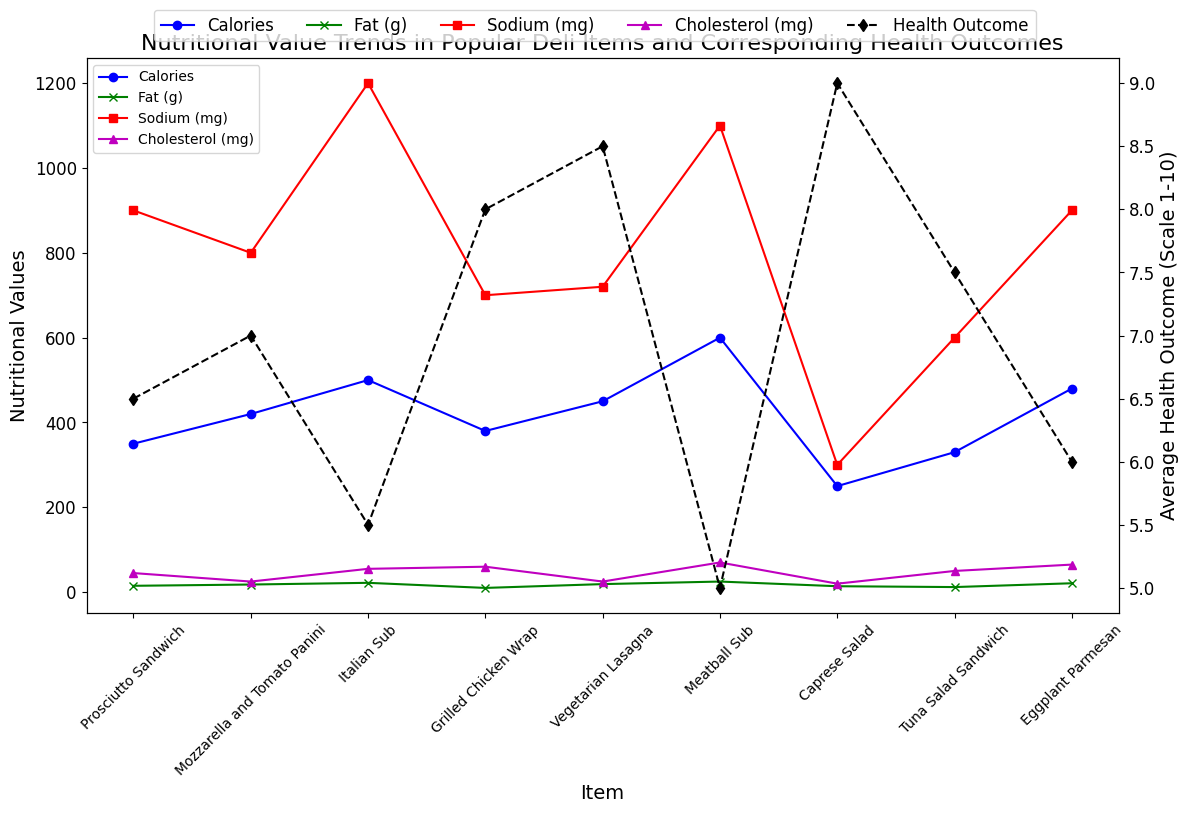Which item has the highest calorie count? Look at the blue line representing calories and find the highest point. The Meatball Sub at 600 calories is the highest.
Answer: Meatball Sub How does the average health outcome of the Caprese Salad compare to that of the Meatball Sub? Find the data points on the dashed black line for both items. Caprese Salad has a score of 9.0, while the Meatball Sub has 5.0, so the Caprese Salad has a higher health outcome.
Answer: Caprese Salad is higher What is the difference in fiber content between the item with the highest fiber and the item with the lowest fiber? Identify the items with the highest and lowest fiber from the green x markers. The Vegetarian Lasagna has the highest at 6g and the Tuna Salad Sandwich has the lowest at 1g. The difference is 6 - 1 = 5g.
Answer: 5g Which item shows an average health outcome of 8.0? Look at the black dashed line and identify the item corresponding to the score of 8.0. The Grilled Chicken Wrap has an average health outcome of 8.0.
Answer: Grilled Chicken Wrap Compare the sodium content of the Italian Sub and the Eggplant Parmesan. Which one is higher? Examine the red square markers for both items. The Italian Sub has 1200 mg, and the Eggplant Parmesan has 900 mg, so the Italian Sub is higher.
Answer: Italian Sub Which item has the least amount of cholesterol and what is its average health outcome? Look at the purple triangle markers and find the lowest point. The Caprese Salad has the least cholesterol at 20 mg, and its health outcome can be seen from the black dashed line at 9.0.
Answer: Caprese Salad; 9.0 What is the sum of the fat content in the Meatball Sub and the Prosciutto Sandwich? Find the fat content from the green x markers for both items: Meatball Sub (25g) and Prosciutto Sandwich (15g). The sum is 25 + 15 = 40g.
Answer: 40g What is the color of the line representing protein content? The lines representing nutritional values are different colors. Protein content is not directly plotted, but since the line is not visible, it implies protein is not specifically a line.
Answer: Not directly plotted What are the two items with the highest average health outcome and what makes them stand out in terms of nutritional values? Look at the black dashed line and find the two highest points: Caprese Salad (9.0) and Vegetarian Lasagna (8.5). They stand out due to relatively high fiber content and lower sodium and cholesterol.
Answer: Caprese Salad, Vegetarian Lasagna What is the relationship between calorie content and average health outcome in the Italian Sub? Compare the blue line for calorie content and the black dashed line for health outcome of the Italian Sub. It has high calories (500) and lower health outcome (5.5), suggesting higher calories may correlate with lower health outcomes.
Answer: High calories, lower health outcome 